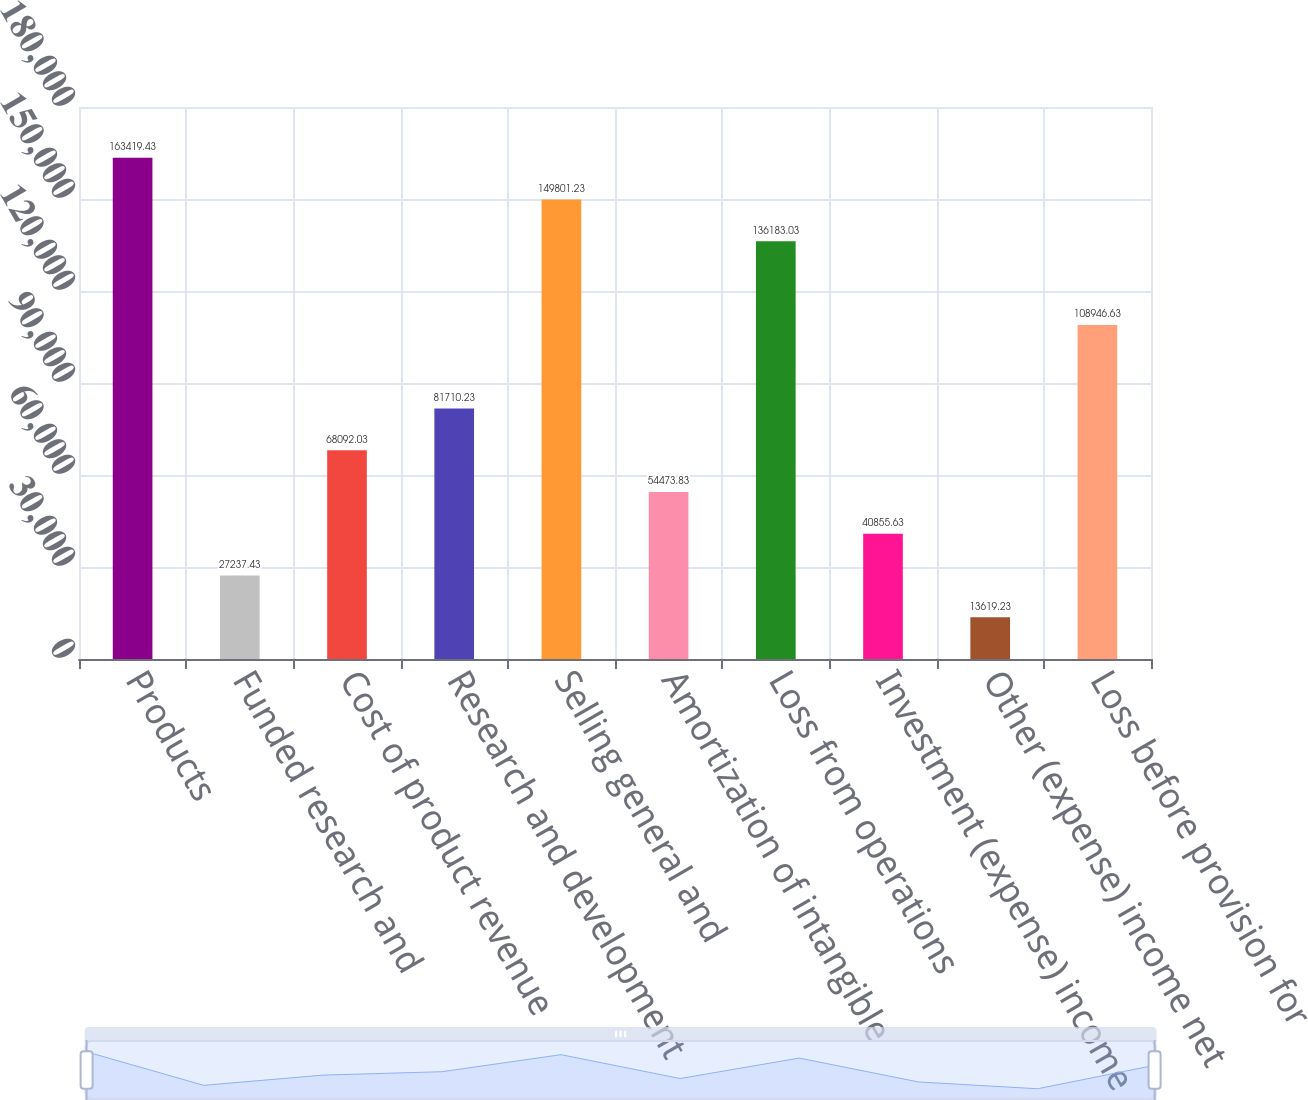Convert chart. <chart><loc_0><loc_0><loc_500><loc_500><bar_chart><fcel>Products<fcel>Funded research and<fcel>Cost of product revenue<fcel>Research and development<fcel>Selling general and<fcel>Amortization of intangible<fcel>Loss from operations<fcel>Investment (expense) income<fcel>Other (expense) income net<fcel>Loss before provision for<nl><fcel>163419<fcel>27237.4<fcel>68092<fcel>81710.2<fcel>149801<fcel>54473.8<fcel>136183<fcel>40855.6<fcel>13619.2<fcel>108947<nl></chart> 